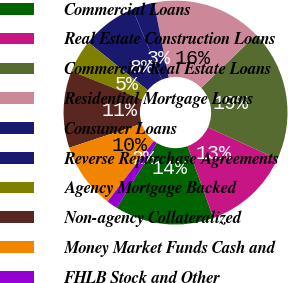Convert chart. <chart><loc_0><loc_0><loc_500><loc_500><pie_chart><fcel>Commercial Loans<fcel>Real Estate Construction Loans<fcel>Commercial Real Estate Loans<fcel>Residential Mortgage Loans<fcel>Consumer Loans<fcel>Reverse Repurchase Agreements<fcel>Agency Mortgage Backed<fcel>Non-agency Collateralized<fcel>Money Market Funds Cash and<fcel>FHLB Stock and Other<nl><fcel>14.28%<fcel>12.7%<fcel>19.04%<fcel>15.87%<fcel>3.18%<fcel>7.94%<fcel>4.77%<fcel>11.11%<fcel>9.52%<fcel>1.59%<nl></chart> 